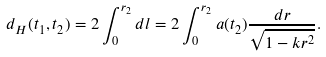<formula> <loc_0><loc_0><loc_500><loc_500>d _ { H } ( t _ { 1 } , t _ { 2 } ) = 2 \int _ { 0 } ^ { r _ { 2 } } d l = 2 \int _ { 0 } ^ { r _ { 2 } } a ( t _ { 2 } ) \frac { d r } { \sqrt { 1 - k r ^ { 2 } } } .</formula> 